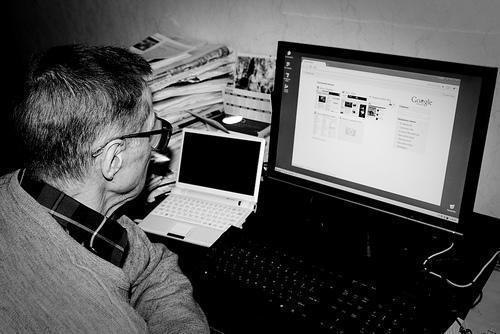How many comps are there?
Give a very brief answer. 2. How many laptops are there?
Give a very brief answer. 2. How many tvs are there?
Give a very brief answer. 2. How many cars are waiting at the cross walk?
Give a very brief answer. 0. 